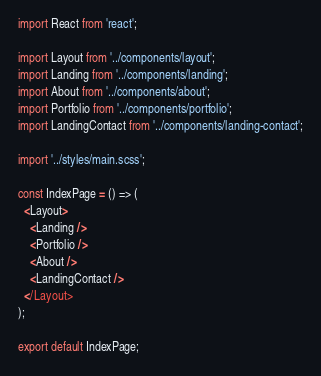Convert code to text. <code><loc_0><loc_0><loc_500><loc_500><_JavaScript_>import React from 'react';

import Layout from '../components/layout';
import Landing from '../components/landing';
import About from '../components/about';
import Portfolio from '../components/portfolio';
import LandingContact from '../components/landing-contact';

import '../styles/main.scss';

const IndexPage = () => (
  <Layout>
    <Landing />
    <Portfolio />
    <About />
    <LandingContact />
  </Layout>
);

export default IndexPage;
</code> 